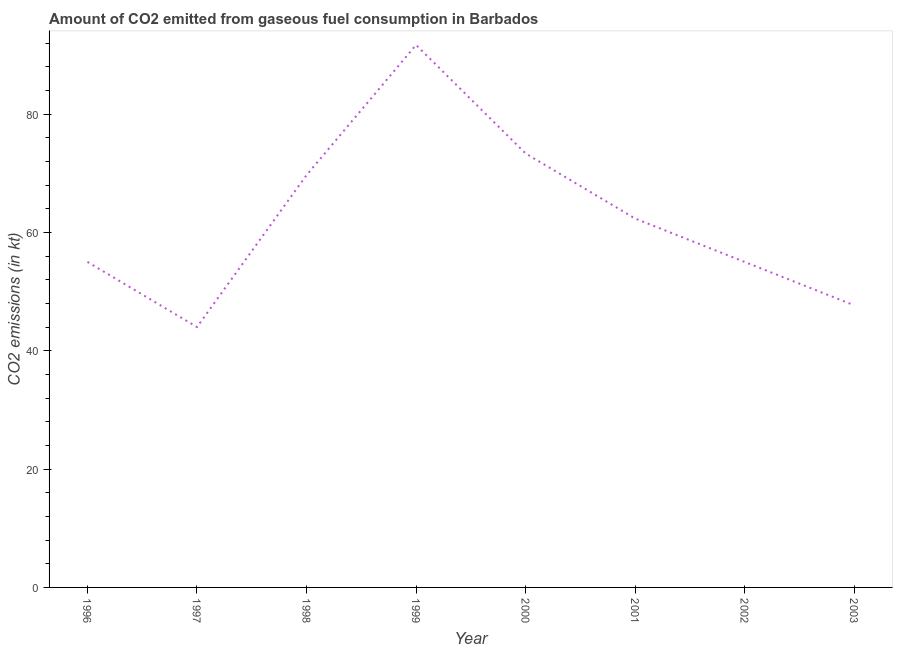What is the co2 emissions from gaseous fuel consumption in 2001?
Offer a very short reply. 62.34. Across all years, what is the maximum co2 emissions from gaseous fuel consumption?
Give a very brief answer. 91.67. Across all years, what is the minimum co2 emissions from gaseous fuel consumption?
Keep it short and to the point. 44. In which year was the co2 emissions from gaseous fuel consumption minimum?
Offer a very short reply. 1997. What is the sum of the co2 emissions from gaseous fuel consumption?
Make the answer very short. 498.71. What is the difference between the co2 emissions from gaseous fuel consumption in 1996 and 2000?
Provide a succinct answer. -18.34. What is the average co2 emissions from gaseous fuel consumption per year?
Keep it short and to the point. 62.34. What is the median co2 emissions from gaseous fuel consumption?
Give a very brief answer. 58.67. What is the ratio of the co2 emissions from gaseous fuel consumption in 1997 to that in 2002?
Make the answer very short. 0.8. What is the difference between the highest and the second highest co2 emissions from gaseous fuel consumption?
Keep it short and to the point. 18.33. What is the difference between the highest and the lowest co2 emissions from gaseous fuel consumption?
Give a very brief answer. 47.67. Does the co2 emissions from gaseous fuel consumption monotonically increase over the years?
Give a very brief answer. No. How many lines are there?
Provide a succinct answer. 1. What is the difference between two consecutive major ticks on the Y-axis?
Your response must be concise. 20. Are the values on the major ticks of Y-axis written in scientific E-notation?
Keep it short and to the point. No. What is the title of the graph?
Offer a terse response. Amount of CO2 emitted from gaseous fuel consumption in Barbados. What is the label or title of the Y-axis?
Make the answer very short. CO2 emissions (in kt). What is the CO2 emissions (in kt) of 1996?
Give a very brief answer. 55.01. What is the CO2 emissions (in kt) in 1997?
Provide a short and direct response. 44. What is the CO2 emissions (in kt) in 1998?
Give a very brief answer. 69.67. What is the CO2 emissions (in kt) of 1999?
Keep it short and to the point. 91.67. What is the CO2 emissions (in kt) of 2000?
Give a very brief answer. 73.34. What is the CO2 emissions (in kt) in 2001?
Provide a short and direct response. 62.34. What is the CO2 emissions (in kt) in 2002?
Offer a terse response. 55.01. What is the CO2 emissions (in kt) of 2003?
Offer a very short reply. 47.67. What is the difference between the CO2 emissions (in kt) in 1996 and 1997?
Make the answer very short. 11. What is the difference between the CO2 emissions (in kt) in 1996 and 1998?
Provide a short and direct response. -14.67. What is the difference between the CO2 emissions (in kt) in 1996 and 1999?
Give a very brief answer. -36.67. What is the difference between the CO2 emissions (in kt) in 1996 and 2000?
Provide a succinct answer. -18.34. What is the difference between the CO2 emissions (in kt) in 1996 and 2001?
Your response must be concise. -7.33. What is the difference between the CO2 emissions (in kt) in 1996 and 2003?
Offer a terse response. 7.33. What is the difference between the CO2 emissions (in kt) in 1997 and 1998?
Provide a short and direct response. -25.67. What is the difference between the CO2 emissions (in kt) in 1997 and 1999?
Your answer should be very brief. -47.67. What is the difference between the CO2 emissions (in kt) in 1997 and 2000?
Offer a very short reply. -29.34. What is the difference between the CO2 emissions (in kt) in 1997 and 2001?
Your response must be concise. -18.34. What is the difference between the CO2 emissions (in kt) in 1997 and 2002?
Give a very brief answer. -11. What is the difference between the CO2 emissions (in kt) in 1997 and 2003?
Provide a succinct answer. -3.67. What is the difference between the CO2 emissions (in kt) in 1998 and 1999?
Keep it short and to the point. -22. What is the difference between the CO2 emissions (in kt) in 1998 and 2000?
Provide a succinct answer. -3.67. What is the difference between the CO2 emissions (in kt) in 1998 and 2001?
Provide a short and direct response. 7.33. What is the difference between the CO2 emissions (in kt) in 1998 and 2002?
Your answer should be very brief. 14.67. What is the difference between the CO2 emissions (in kt) in 1998 and 2003?
Your answer should be very brief. 22. What is the difference between the CO2 emissions (in kt) in 1999 and 2000?
Provide a short and direct response. 18.34. What is the difference between the CO2 emissions (in kt) in 1999 and 2001?
Offer a terse response. 29.34. What is the difference between the CO2 emissions (in kt) in 1999 and 2002?
Provide a short and direct response. 36.67. What is the difference between the CO2 emissions (in kt) in 1999 and 2003?
Keep it short and to the point. 44. What is the difference between the CO2 emissions (in kt) in 2000 and 2001?
Your response must be concise. 11. What is the difference between the CO2 emissions (in kt) in 2000 and 2002?
Your answer should be very brief. 18.34. What is the difference between the CO2 emissions (in kt) in 2000 and 2003?
Your response must be concise. 25.67. What is the difference between the CO2 emissions (in kt) in 2001 and 2002?
Your answer should be compact. 7.33. What is the difference between the CO2 emissions (in kt) in 2001 and 2003?
Provide a short and direct response. 14.67. What is the difference between the CO2 emissions (in kt) in 2002 and 2003?
Provide a short and direct response. 7.33. What is the ratio of the CO2 emissions (in kt) in 1996 to that in 1997?
Your answer should be very brief. 1.25. What is the ratio of the CO2 emissions (in kt) in 1996 to that in 1998?
Offer a very short reply. 0.79. What is the ratio of the CO2 emissions (in kt) in 1996 to that in 1999?
Make the answer very short. 0.6. What is the ratio of the CO2 emissions (in kt) in 1996 to that in 2001?
Provide a short and direct response. 0.88. What is the ratio of the CO2 emissions (in kt) in 1996 to that in 2002?
Provide a short and direct response. 1. What is the ratio of the CO2 emissions (in kt) in 1996 to that in 2003?
Offer a very short reply. 1.15. What is the ratio of the CO2 emissions (in kt) in 1997 to that in 1998?
Offer a very short reply. 0.63. What is the ratio of the CO2 emissions (in kt) in 1997 to that in 1999?
Provide a short and direct response. 0.48. What is the ratio of the CO2 emissions (in kt) in 1997 to that in 2001?
Your response must be concise. 0.71. What is the ratio of the CO2 emissions (in kt) in 1997 to that in 2003?
Ensure brevity in your answer.  0.92. What is the ratio of the CO2 emissions (in kt) in 1998 to that in 1999?
Your response must be concise. 0.76. What is the ratio of the CO2 emissions (in kt) in 1998 to that in 2001?
Your response must be concise. 1.12. What is the ratio of the CO2 emissions (in kt) in 1998 to that in 2002?
Offer a terse response. 1.27. What is the ratio of the CO2 emissions (in kt) in 1998 to that in 2003?
Offer a terse response. 1.46. What is the ratio of the CO2 emissions (in kt) in 1999 to that in 2000?
Ensure brevity in your answer.  1.25. What is the ratio of the CO2 emissions (in kt) in 1999 to that in 2001?
Keep it short and to the point. 1.47. What is the ratio of the CO2 emissions (in kt) in 1999 to that in 2002?
Give a very brief answer. 1.67. What is the ratio of the CO2 emissions (in kt) in 1999 to that in 2003?
Provide a short and direct response. 1.92. What is the ratio of the CO2 emissions (in kt) in 2000 to that in 2001?
Offer a very short reply. 1.18. What is the ratio of the CO2 emissions (in kt) in 2000 to that in 2002?
Offer a very short reply. 1.33. What is the ratio of the CO2 emissions (in kt) in 2000 to that in 2003?
Your response must be concise. 1.54. What is the ratio of the CO2 emissions (in kt) in 2001 to that in 2002?
Keep it short and to the point. 1.13. What is the ratio of the CO2 emissions (in kt) in 2001 to that in 2003?
Your response must be concise. 1.31. What is the ratio of the CO2 emissions (in kt) in 2002 to that in 2003?
Make the answer very short. 1.15. 